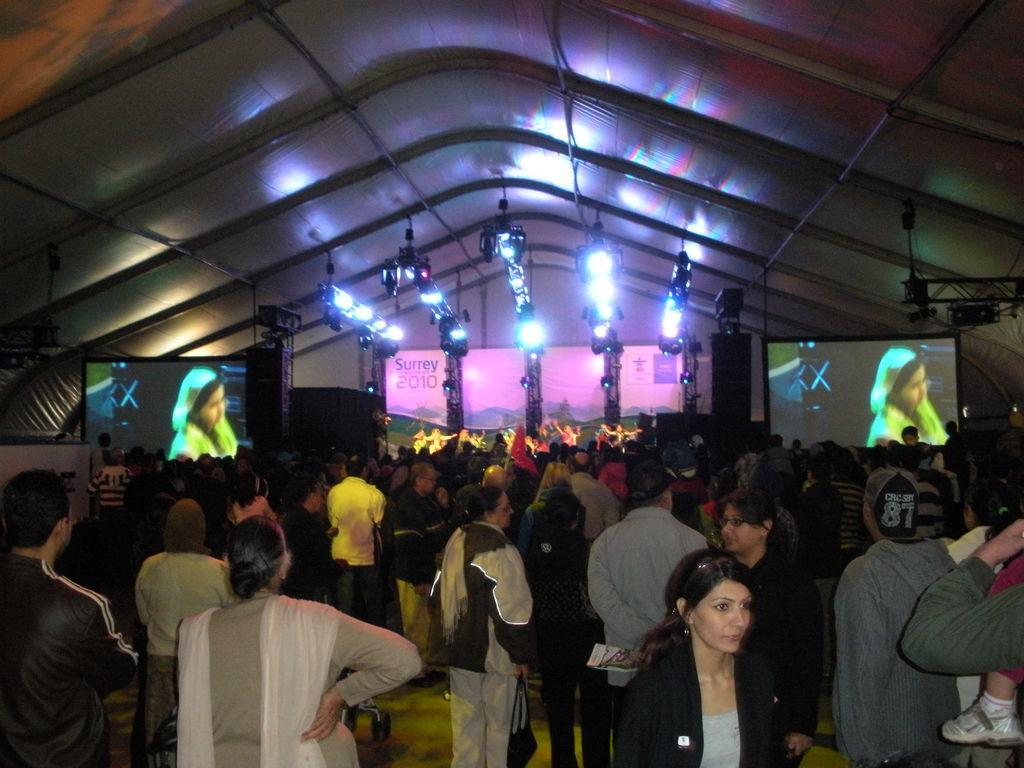Please provide a concise description of this image. In this image there are some persons standing at bottom of this image and there are some screens in the background and there are some lights arranged at top of this image and as we can see there is a roof at top of this image. 